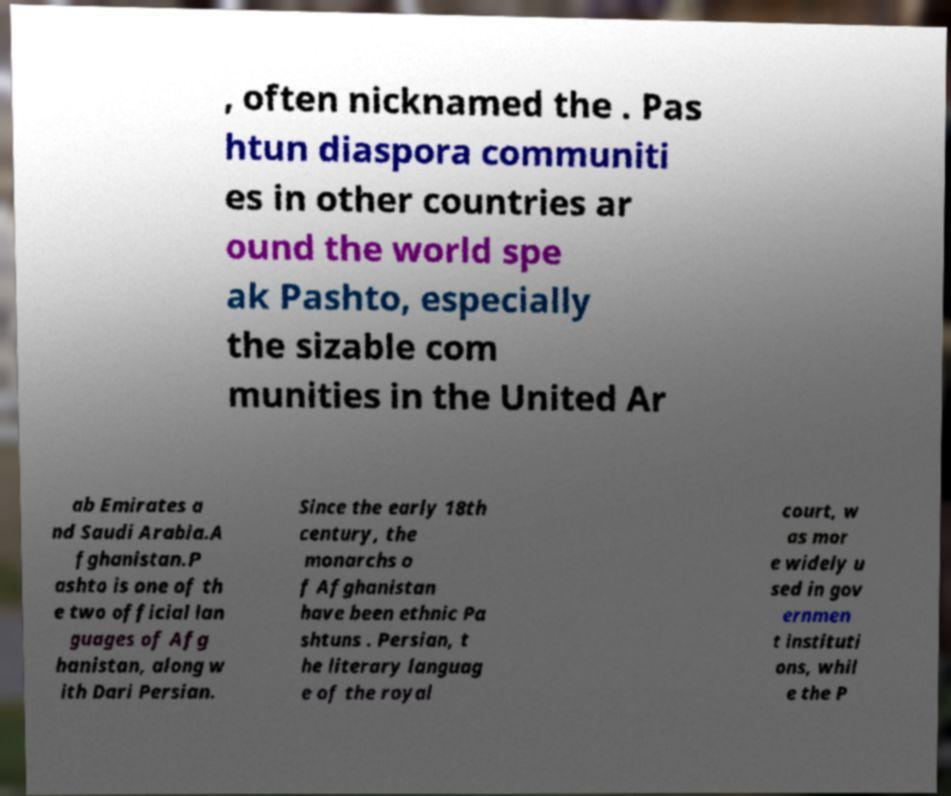Can you read and provide the text displayed in the image?This photo seems to have some interesting text. Can you extract and type it out for me? , often nicknamed the . Pas htun diaspora communiti es in other countries ar ound the world spe ak Pashto, especially the sizable com munities in the United Ar ab Emirates a nd Saudi Arabia.A fghanistan.P ashto is one of th e two official lan guages of Afg hanistan, along w ith Dari Persian. Since the early 18th century, the monarchs o f Afghanistan have been ethnic Pa shtuns . Persian, t he literary languag e of the royal court, w as mor e widely u sed in gov ernmen t instituti ons, whil e the P 